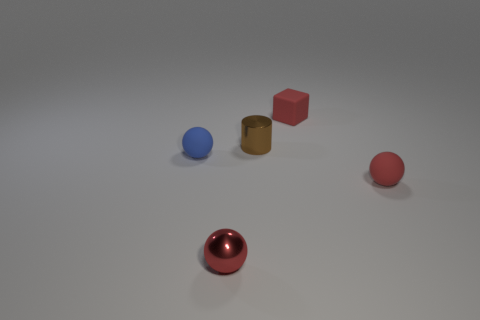Subtract all purple cylinders. How many red balls are left? 2 Subtract 1 balls. How many balls are left? 2 Add 5 tiny brown cylinders. How many objects exist? 10 Subtract all balls. How many objects are left? 2 Add 1 tiny blue matte things. How many tiny blue matte things are left? 2 Add 4 rubber cubes. How many rubber cubes exist? 5 Subtract 0 yellow blocks. How many objects are left? 5 Subtract all tiny red matte blocks. Subtract all metal things. How many objects are left? 2 